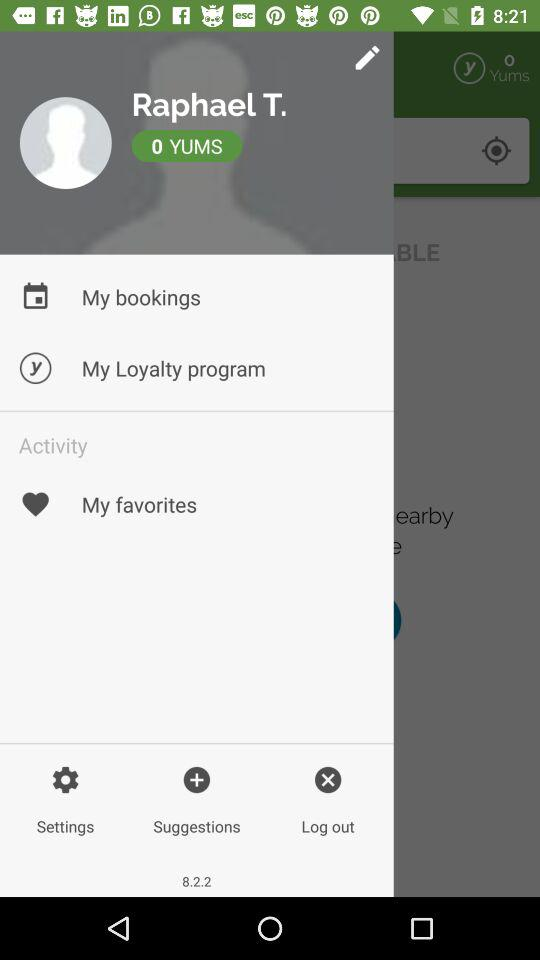What is the version? The version is 8.2.2. 